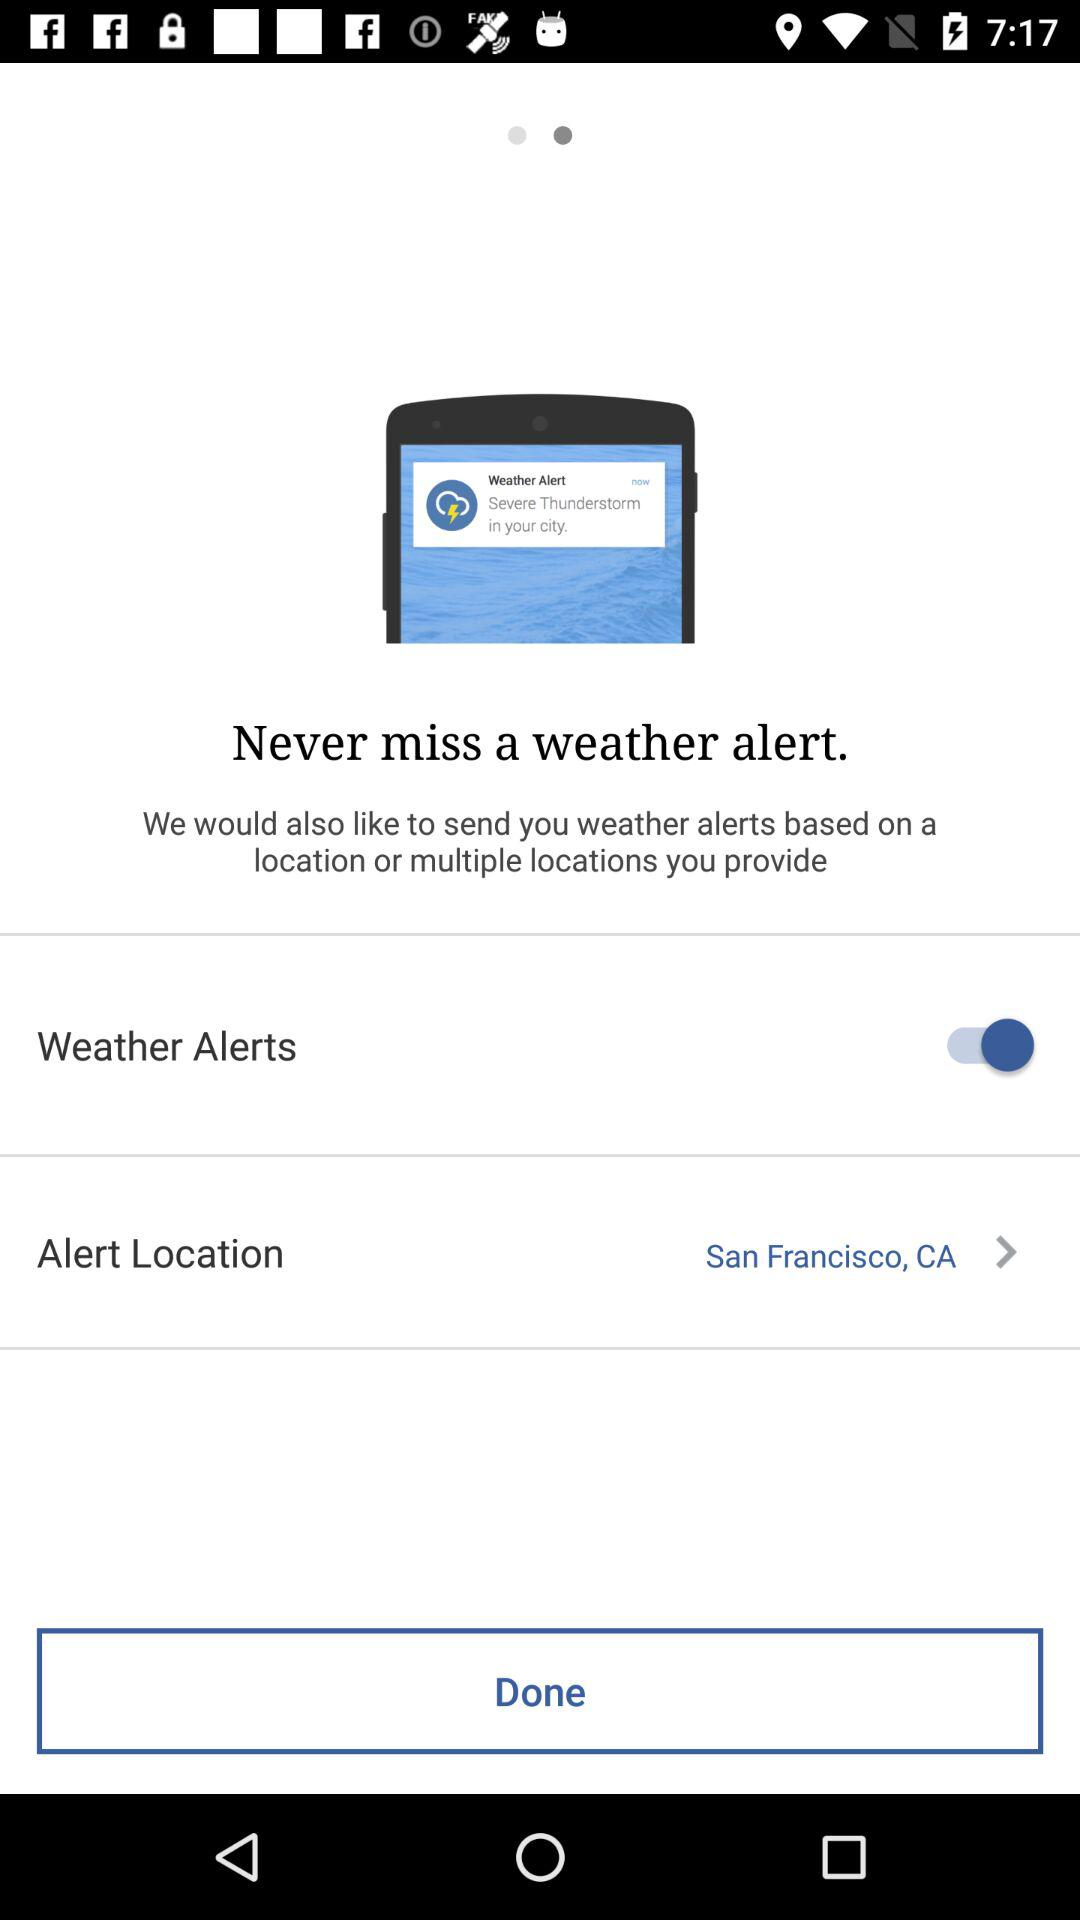What is the status of "Weather Alerts"? The status is "on". 